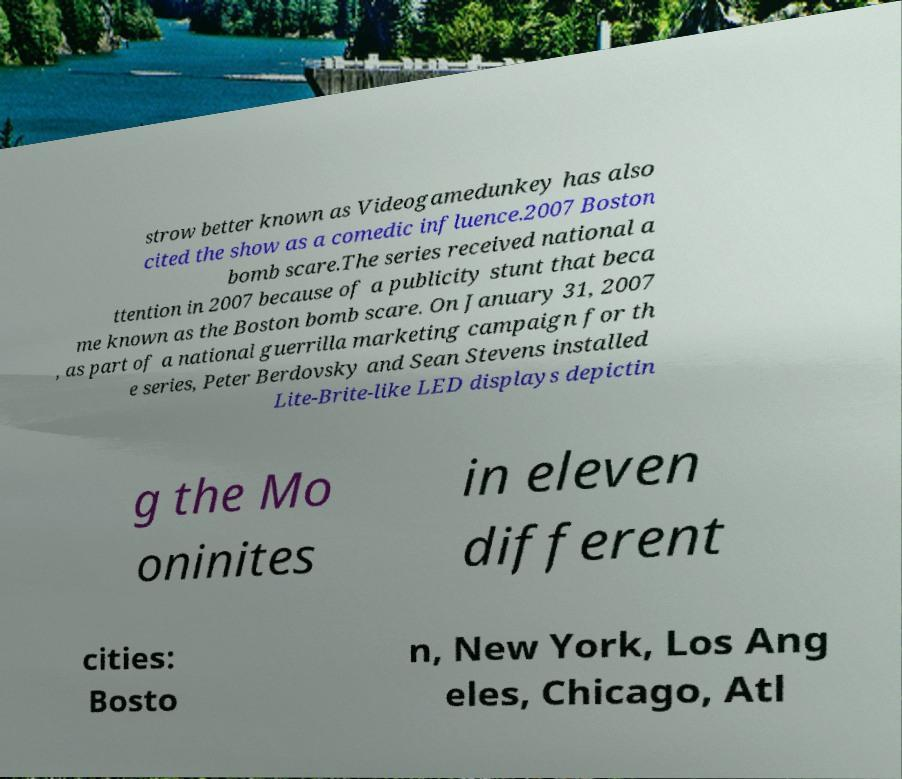Could you extract and type out the text from this image? strow better known as Videogamedunkey has also cited the show as a comedic influence.2007 Boston bomb scare.The series received national a ttention in 2007 because of a publicity stunt that beca me known as the Boston bomb scare. On January 31, 2007 , as part of a national guerrilla marketing campaign for th e series, Peter Berdovsky and Sean Stevens installed Lite-Brite-like LED displays depictin g the Mo oninites in eleven different cities: Bosto n, New York, Los Ang eles, Chicago, Atl 